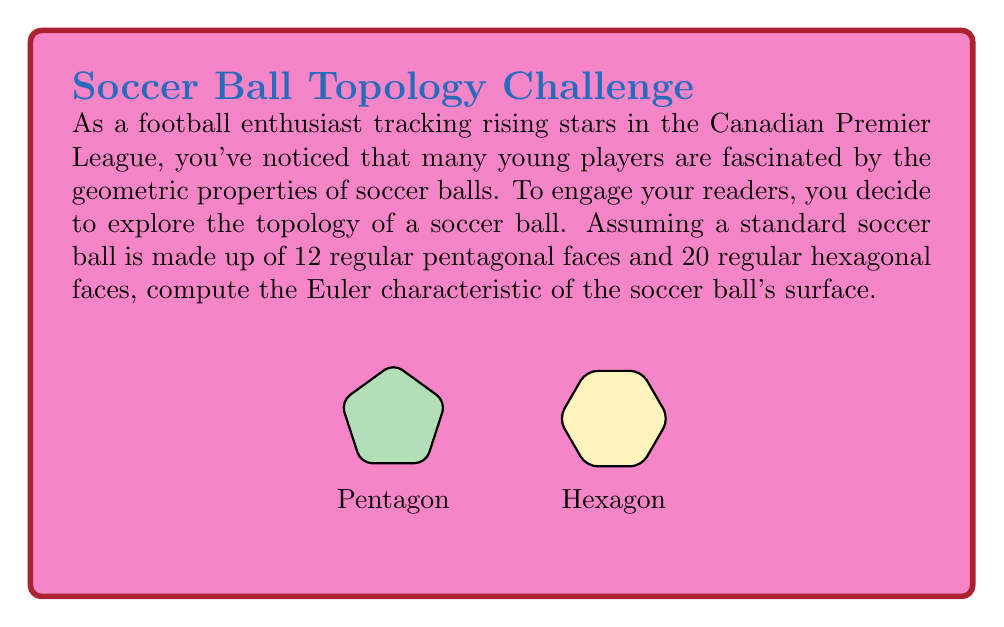Can you answer this question? To compute the Euler characteristic of the soccer ball's surface, we'll use the formula:

$$\chi = V - E + F$$

Where:
$\chi$ is the Euler characteristic
$V$ is the number of vertices
$E$ is the number of edges
$F$ is the number of faces

Let's calculate each component:

1. Faces (F):
   We're given that there are 12 pentagonal faces and 20 hexagonal faces.
   $$F = 12 + 20 = 32$$

2. Edges (E):
   Each edge is shared by two faces. We can count the total edges by:
   - Pentagons contribute: $12 \times 5 = 60$ half-edges
   - Hexagons contribute: $20 \times 6 = 120$ half-edges
   Total half-edges: $60 + 120 = 180$
   $$E = 180 \div 2 = 90$$

3. Vertices (V):
   To find the number of vertices, we can use the fact that in a soccer ball, each vertex is where three faces meet (two hexagons and one pentagon).
   Total vertex-face connections: $12 \times 5 + 20 \times 6 = 180$
   $$V = 180 \div 3 = 60$$

Now we can substitute these values into the Euler characteristic formula:

$$\chi = V - E + F = 60 - 90 + 32 = 2$$

This result, $\chi = 2$, is consistent with the Euler characteristic of a sphere, which a soccer ball approximates.
Answer: $\chi = 2$ 